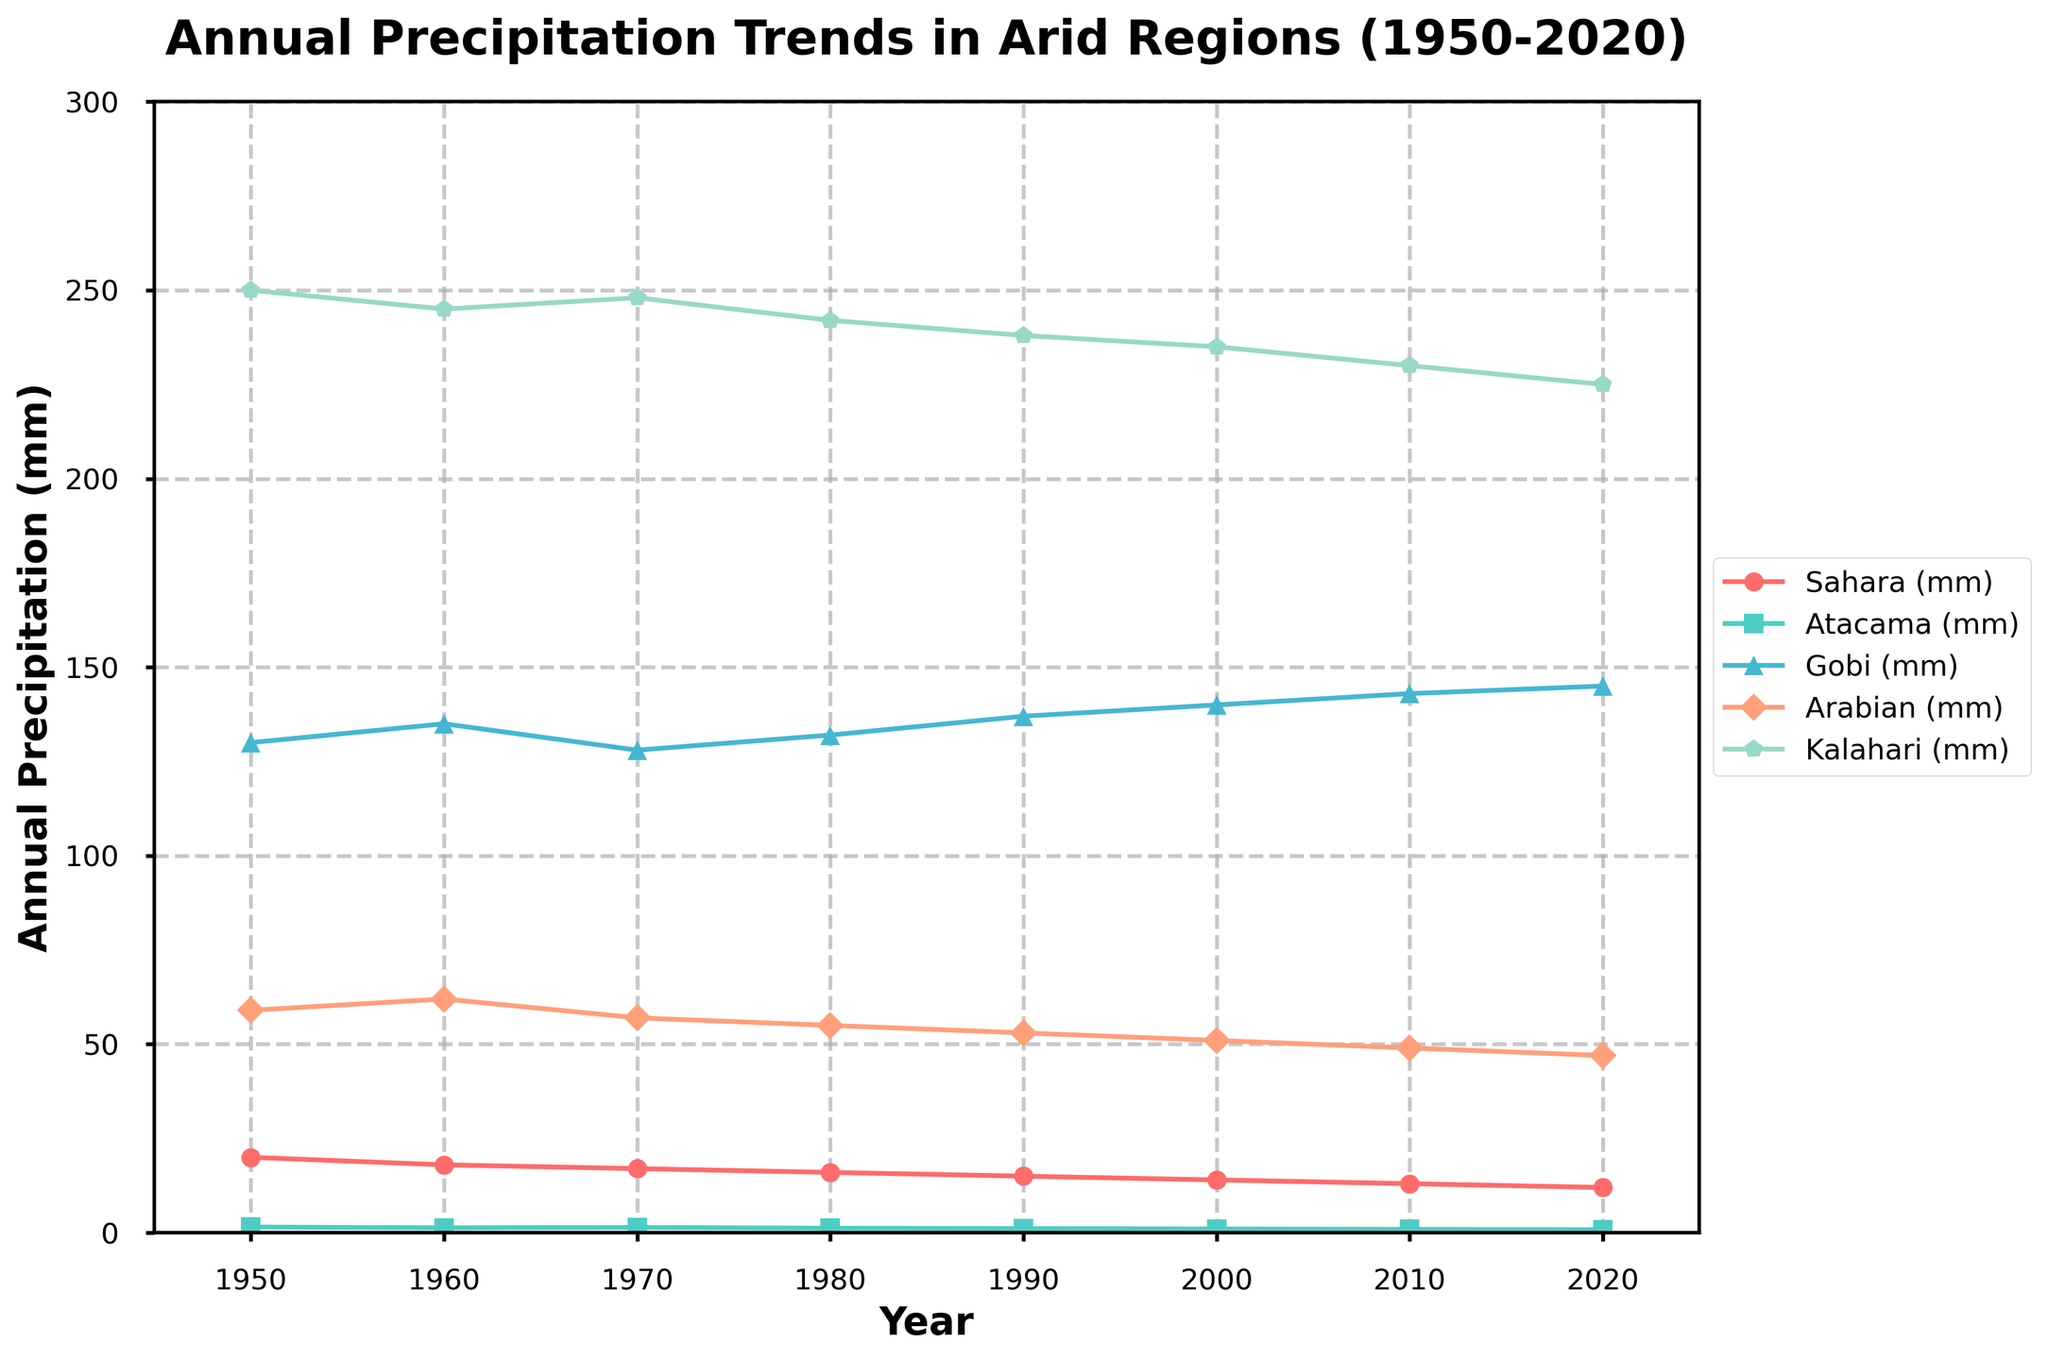What is the general trend of annual precipitation in the Sahara region from 1950 to 2020? The precipitation in the Sahara declines from 20 mm in 1950 to 12 mm in 2020, showing a consistent downward trend over the years.
Answer: Downward trend Which arid region has the least annual precipitation in 2020? In 2020, the Atacama region has the least annual precipitation, with 0.8 mm of rainfall.
Answer: Atacama What is the difference in annual precipitation between the Gobi and Arabian regions in 1990? The Gobi had 137 mm and the Arabian had 53 mm of precipitation in 1990. The difference is 137 - 53 = 84 mm.
Answer: 84 mm What is the average annual precipitation of the Kalahari region over the entire period (1950-2020)? Adding the precipitation values for the Kalahari from 1950 to 2020: 250+245+248+242+238+235+230+225 = 1913 mm, and dividing by the number of years (8), we get an average of 1913/8 = 239.125 mm.
Answer: 239.1 mm Which region shows the most consistent annual precipitation from 1950 to 2020 based on the visual trend lines? The Atacama region shows the most consistent (least variation) precipitation with minor fluctuations around a median value.
Answer: Atacama By how much did the precipitation in the Sahara decrease from 1950 to 2020? The precipitation in the Sahara decreased from 20 mm in 1950 to 12 mm in 2020. The decrease is 20 - 12 = 8 mm.
Answer: 8 mm In which decade did the Gobi region see the highest precipitation? The Gobi region saw its highest precipitation in the 2020s with 145 mm.
Answer: 2020s Compare the rates of decline in precipitation for the Sahara and Arabian regions between 1950 and 2020. The Sahara decreased from 20 mm to 12 mm (a difference of 8 mm), while the Arabian decreased from 59 mm to 47 mm (a difference of 12 mm). The Arabian region has a greater rate of decline.
Answer: Arabian Which region saw an increase in precipitation from 1950 to 2020? The Gobi region saw an increase in precipitation from 130 mm in 1950 to 145 mm in 2020.
Answer: Gobi If the trend continues, predict the annual precipitation for the Atacama region in 2030. Assuming a linear decrease of 0.1 mm every decade, the prediction for 2030 would be 0.8 - 0.1 = 0.7 mm.
Answer: 0.7 mm 